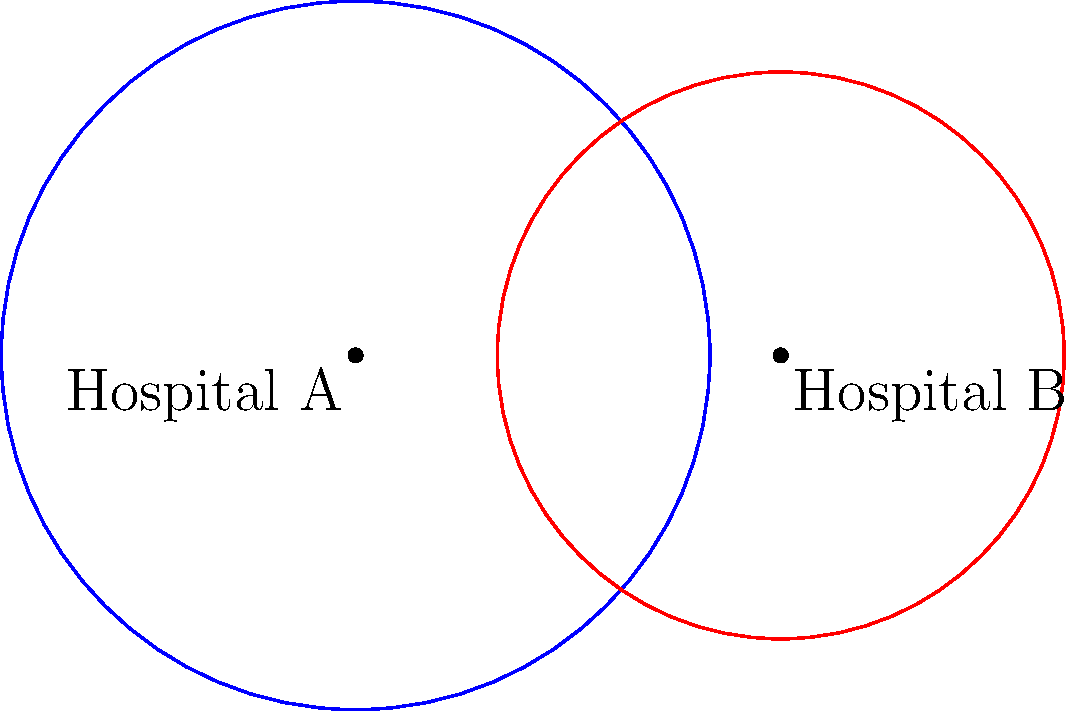Two hospitals, A and B, have circular service regions as shown in the diagram. Hospital A's service region has a radius of 2.5 units, while Hospital B's has a radius of 2 units. The centers of these regions are 3 units apart. What percentage of Hospital B's service area is also covered by Hospital A? Round your answer to the nearest whole percent. To solve this problem, we need to calculate the area of overlap between the two circles and compare it to the area of Hospital B's service region. Let's break it down step-by-step:

1) First, we need to find the area of overlap between the two circles. The formula for this is:

   $$A = r_1^2 \arccos(\frac{d^2 + r_1^2 - r_2^2}{2dr_1}) + r_2^2 \arccos(\frac{d^2 + r_2^2 - r_1^2}{2dr_2}) - \frac{1}{2}\sqrt{(-d+r_1+r_2)(d+r_1-r_2)(d-r_1+r_2)(d+r_1+r_2)}$$

   Where $r_1 = 2.5$, $r_2 = 2$, and $d = 3$ (the distance between centers)

2) Plugging in these values:

   $$A = 2.5^2 \arccos(\frac{3^2 + 2.5^2 - 2^2}{2 \cdot 3 \cdot 2.5}) + 2^2 \arccos(\frac{3^2 + 2^2 - 2.5^2}{2 \cdot 3 \cdot 2}) - \frac{1}{2}\sqrt{(-3+2.5+2)(3+2.5-2)(3-2.5+2)(3+2.5+2)}$$

3) Calculating this (you would use a calculator):

   $$A \approx 4.5358$$ square units

4) Now, we need to calculate the total area of Hospital B's service region:

   $$A_B = \pi r_2^2 = \pi \cdot 2^2 = 4\pi \approx 12.5664$$ square units

5) The percentage of Hospital B's area that is covered by Hospital A is:

   $$\frac{4.5358}{12.5664} \cdot 100\% \approx 36.09\%$$

6) Rounding to the nearest whole percent gives us 36%.
Answer: 36% 